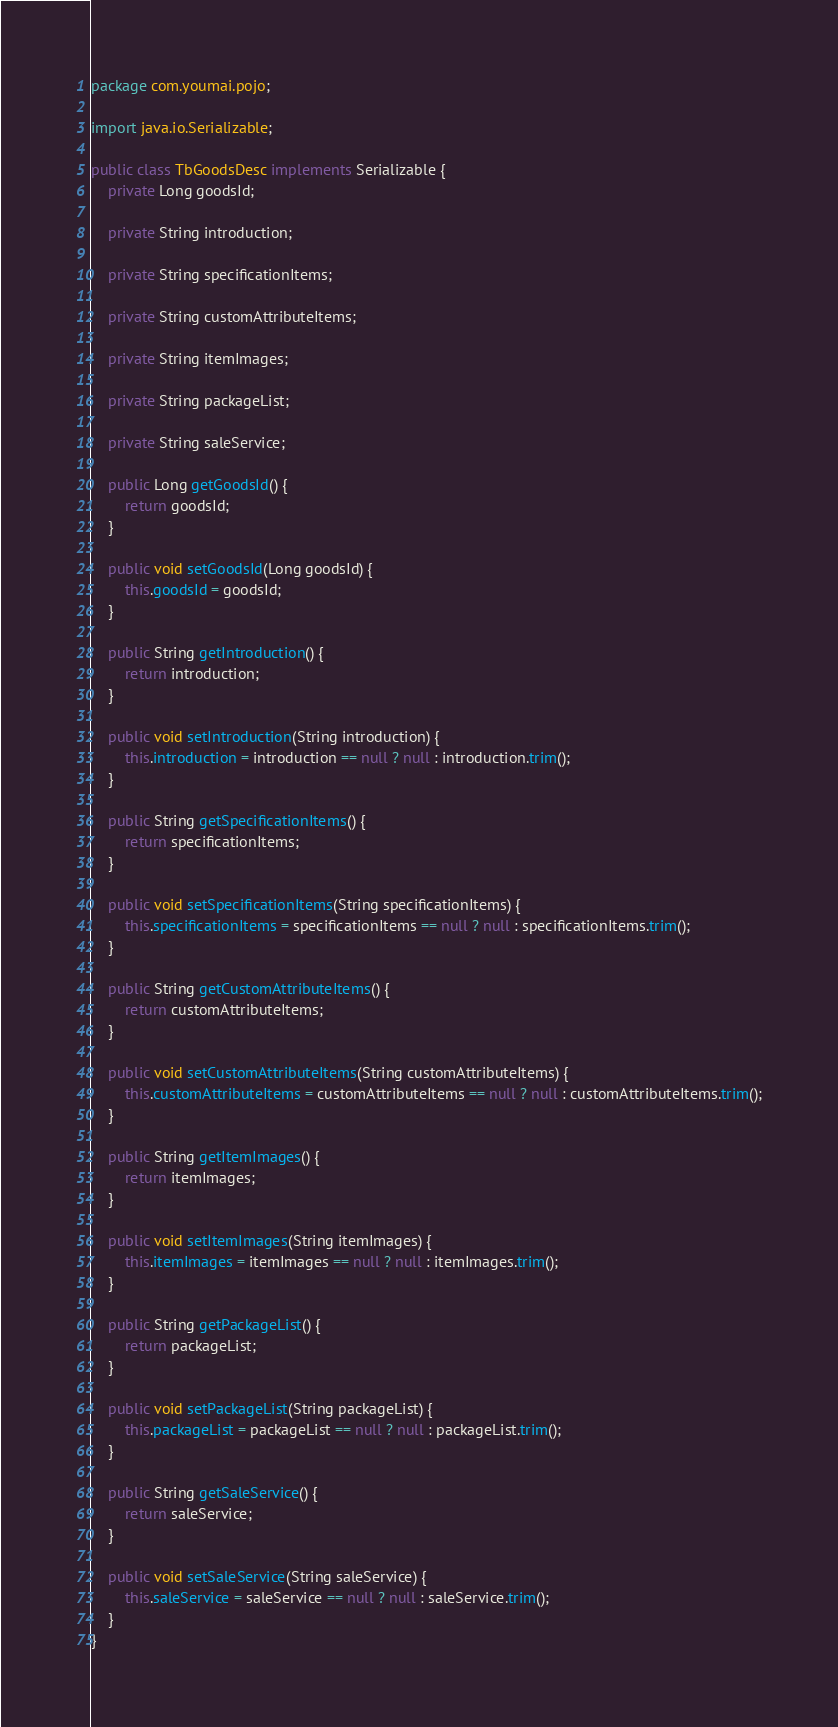<code> <loc_0><loc_0><loc_500><loc_500><_Java_>package com.youmai.pojo;

import java.io.Serializable;

public class TbGoodsDesc implements Serializable {
    private Long goodsId;

    private String introduction;

    private String specificationItems;

    private String customAttributeItems;

    private String itemImages;

    private String packageList;

    private String saleService;

    public Long getGoodsId() {
        return goodsId;
    }

    public void setGoodsId(Long goodsId) {
        this.goodsId = goodsId;
    }

    public String getIntroduction() {
        return introduction;
    }

    public void setIntroduction(String introduction) {
        this.introduction = introduction == null ? null : introduction.trim();
    }

    public String getSpecificationItems() {
        return specificationItems;
    }

    public void setSpecificationItems(String specificationItems) {
        this.specificationItems = specificationItems == null ? null : specificationItems.trim();
    }

    public String getCustomAttributeItems() {
        return customAttributeItems;
    }

    public void setCustomAttributeItems(String customAttributeItems) {
        this.customAttributeItems = customAttributeItems == null ? null : customAttributeItems.trim();
    }

    public String getItemImages() {
        return itemImages;
    }

    public void setItemImages(String itemImages) {
        this.itemImages = itemImages == null ? null : itemImages.trim();
    }

    public String getPackageList() {
        return packageList;
    }

    public void setPackageList(String packageList) {
        this.packageList = packageList == null ? null : packageList.trim();
    }

    public String getSaleService() {
        return saleService;
    }

    public void setSaleService(String saleService) {
        this.saleService = saleService == null ? null : saleService.trim();
    }
}</code> 